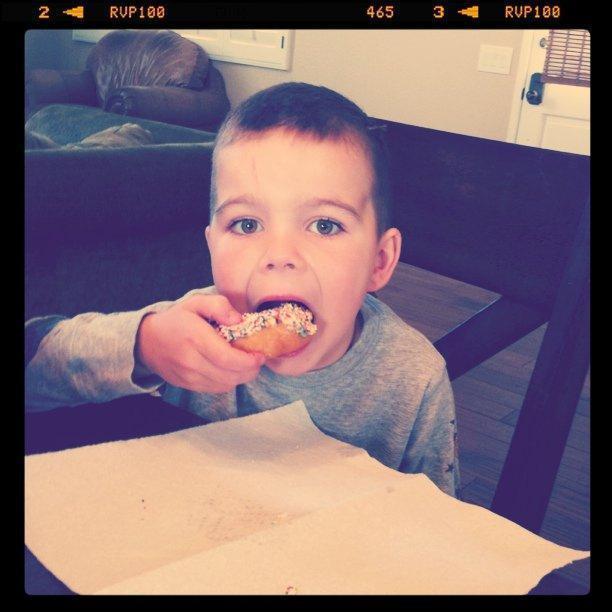How many couches are there?
Give a very brief answer. 2. How many chairs are visible?
Give a very brief answer. 2. 